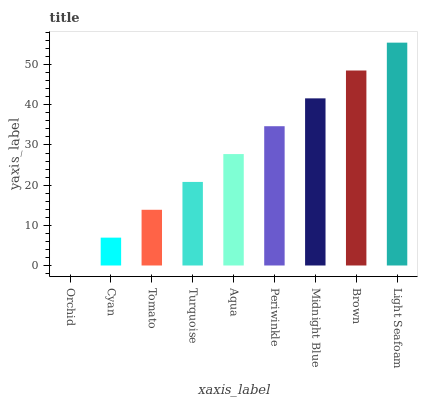Is Cyan the minimum?
Answer yes or no. No. Is Cyan the maximum?
Answer yes or no. No. Is Cyan greater than Orchid?
Answer yes or no. Yes. Is Orchid less than Cyan?
Answer yes or no. Yes. Is Orchid greater than Cyan?
Answer yes or no. No. Is Cyan less than Orchid?
Answer yes or no. No. Is Aqua the high median?
Answer yes or no. Yes. Is Aqua the low median?
Answer yes or no. Yes. Is Midnight Blue the high median?
Answer yes or no. No. Is Periwinkle the low median?
Answer yes or no. No. 